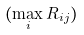Convert formula to latex. <formula><loc_0><loc_0><loc_500><loc_500>( \max _ { i } R _ { i j } )</formula> 